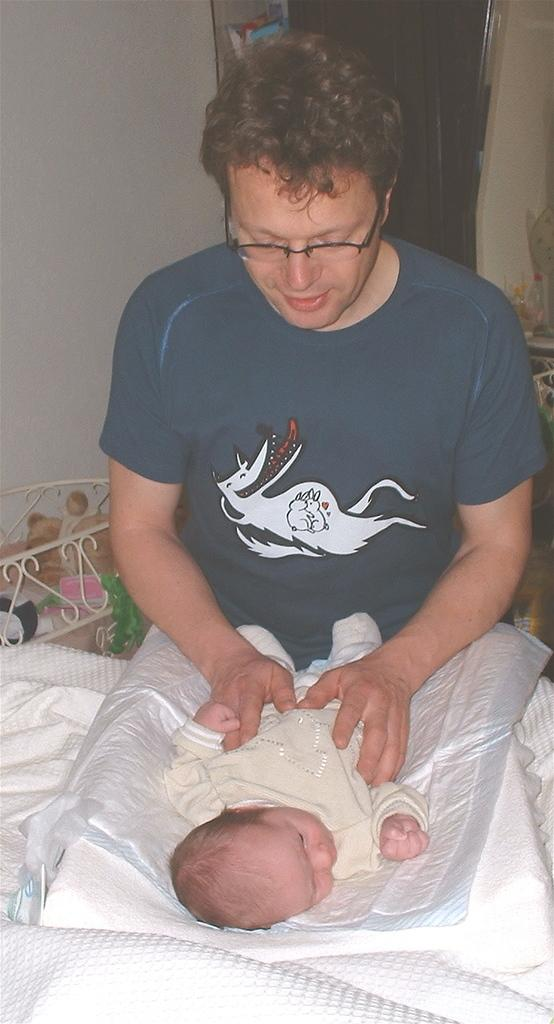Who is present in the image? There is a person in the image. What is the baby doing in the image? A baby is lying in front of the person. What is the person doing in the image? The person is looking at the baby. What can be seen in the background of the image? There are things visible in the background, including a curtain. What is the purpose of the card on the table in the image? There is no card present on the table in the image. 